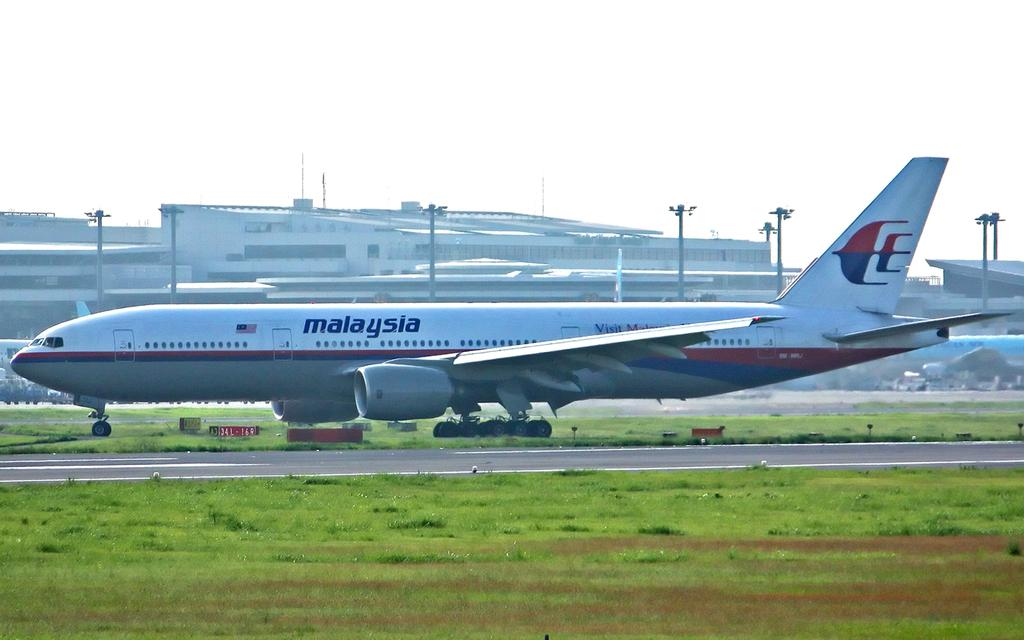<image>
Provide a brief description of the given image. A Mayayisan airplane sits  on the grass beside a runway. 